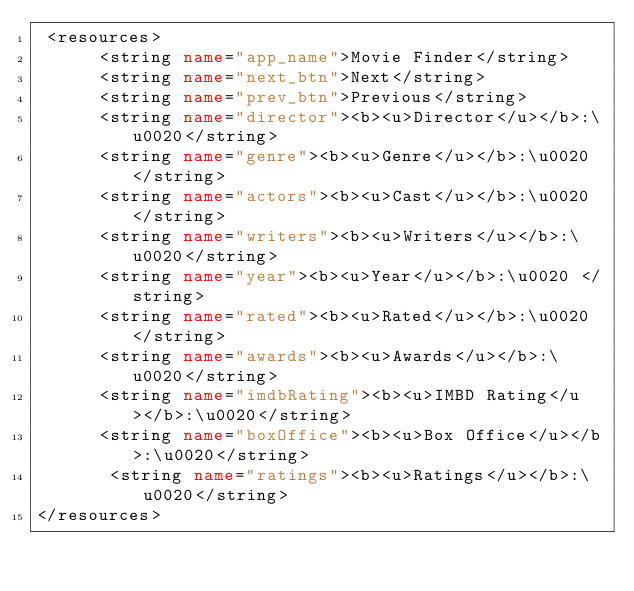Convert code to text. <code><loc_0><loc_0><loc_500><loc_500><_XML_> <resources>
      <string name="app_name">Movie Finder</string>
      <string name="next_btn">Next</string>
      <string name="prev_btn">Previous</string>
      <string name="director"><b><u>Director</u></b>:\u0020</string>
      <string name="genre"><b><u>Genre</u></b>:\u0020</string>
      <string name="actors"><b><u>Cast</u></b>:\u0020</string>
      <string name="writers"><b><u>Writers</u></b>:\u0020</string>
      <string name="year"><b><u>Year</u></b>:\u0020 </string>
      <string name="rated"><b><u>Rated</u></b>:\u0020</string>
      <string name="awards"><b><u>Awards</u></b>:\u0020</string>
      <string name="imdbRating"><b><u>IMBD Rating</u></b>:\u0020</string>
      <string name="boxOffice"><b><u>Box Office</u></b>:\u0020</string>
       <string name="ratings"><b><u>Ratings</u></b>:\u0020</string>
</resources>
</code> 